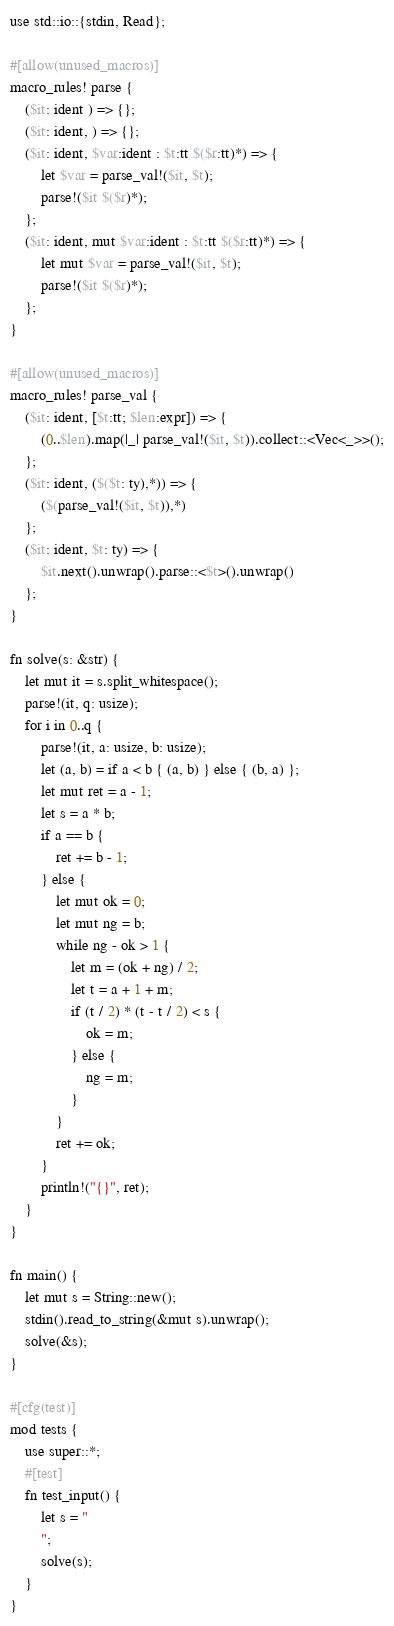<code> <loc_0><loc_0><loc_500><loc_500><_Rust_>use std::io::{stdin, Read};

#[allow(unused_macros)]
macro_rules! parse {
    ($it: ident ) => {};
    ($it: ident, ) => {};
    ($it: ident, $var:ident : $t:tt $($r:tt)*) => {
        let $var = parse_val!($it, $t);
        parse!($it $($r)*);
    };
    ($it: ident, mut $var:ident : $t:tt $($r:tt)*) => {
        let mut $var = parse_val!($it, $t);
        parse!($it $($r)*);
    };
}

#[allow(unused_macros)]
macro_rules! parse_val {
    ($it: ident, [$t:tt; $len:expr]) => {
        (0..$len).map(|_| parse_val!($it, $t)).collect::<Vec<_>>();
    };
    ($it: ident, ($($t: ty),*)) => {
        ($(parse_val!($it, $t)),*)
    };
    ($it: ident, $t: ty) => {
        $it.next().unwrap().parse::<$t>().unwrap()
    };
}

fn solve(s: &str) {
    let mut it = s.split_whitespace();
    parse!(it, q: usize);
    for i in 0..q {
        parse!(it, a: usize, b: usize);
        let (a, b) = if a < b { (a, b) } else { (b, a) };
        let mut ret = a - 1;
        let s = a * b;
        if a == b {
            ret += b - 1;
        } else {
            let mut ok = 0;
            let mut ng = b;
            while ng - ok > 1 {
                let m = (ok + ng) / 2;
                let t = a + 1 + m;
                if (t / 2) * (t - t / 2) < s {
                    ok = m;
                } else {
                    ng = m;
                }
            }
            ret += ok;
        }
        println!("{}", ret);
    }
}

fn main() {
    let mut s = String::new();
    stdin().read_to_string(&mut s).unwrap();
    solve(&s);
}

#[cfg(test)]
mod tests {
    use super::*;
    #[test]
    fn test_input() {
        let s = "
        ";
        solve(s);
    }
}
</code> 